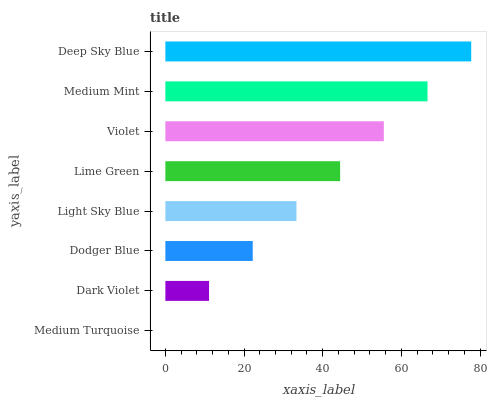Is Medium Turquoise the minimum?
Answer yes or no. Yes. Is Deep Sky Blue the maximum?
Answer yes or no. Yes. Is Dark Violet the minimum?
Answer yes or no. No. Is Dark Violet the maximum?
Answer yes or no. No. Is Dark Violet greater than Medium Turquoise?
Answer yes or no. Yes. Is Medium Turquoise less than Dark Violet?
Answer yes or no. Yes. Is Medium Turquoise greater than Dark Violet?
Answer yes or no. No. Is Dark Violet less than Medium Turquoise?
Answer yes or no. No. Is Lime Green the high median?
Answer yes or no. Yes. Is Light Sky Blue the low median?
Answer yes or no. Yes. Is Light Sky Blue the high median?
Answer yes or no. No. Is Dodger Blue the low median?
Answer yes or no. No. 